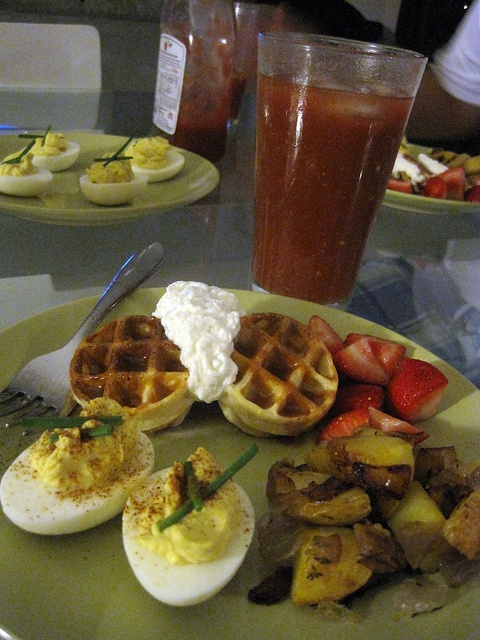Describe the objects in this image and their specific colors. I can see dining table in olive, maroon, black, and gray tones, cup in black, maroon, and gray tones, bottle in black, maroon, and gray tones, people in black, gray, and darkgray tones, and fork in black, gray, darkgray, and darkgreen tones in this image. 